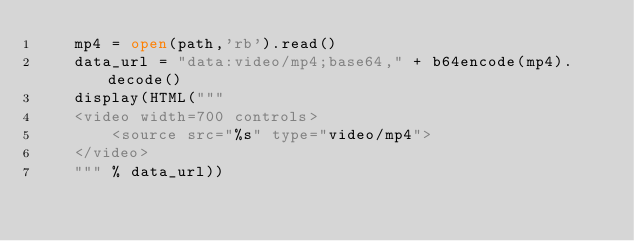<code> <loc_0><loc_0><loc_500><loc_500><_Python_>    mp4 = open(path,'rb').read()
    data_url = "data:video/mp4;base64," + b64encode(mp4).decode()
    display(HTML("""
    <video width=700 controls>
        <source src="%s" type="video/mp4">
    </video>
    """ % data_url))</code> 